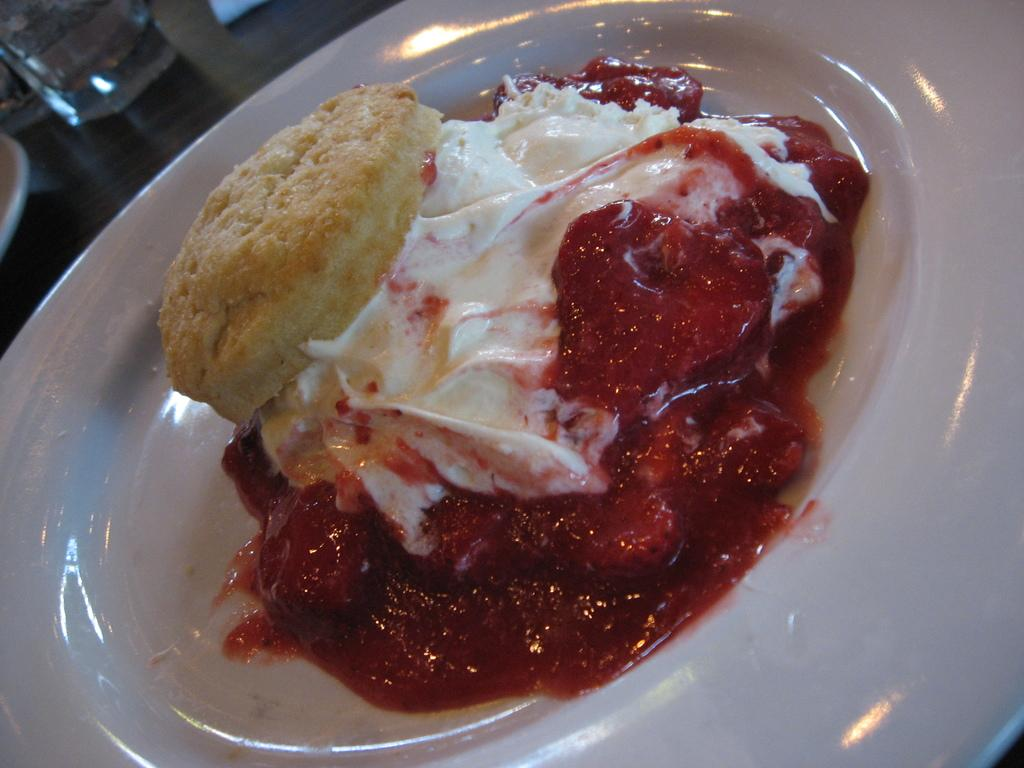What piece of furniture is present in the image? There is a table in the image. What is placed on the table? There is a plate on the table, and the plate contains a food item. What type of container is also on the table? There is a glass on the table. Are there any other items on the table? Yes, there are other objects on the table. Can you see any ants crawling on the food item in the image? There is no mention of ants in the provided facts, so we cannot determine if any are present in the image. What type of drink is in the glass on the table? The provided facts do not specify the contents of the glass, so we cannot determine what type of drink is in it. 